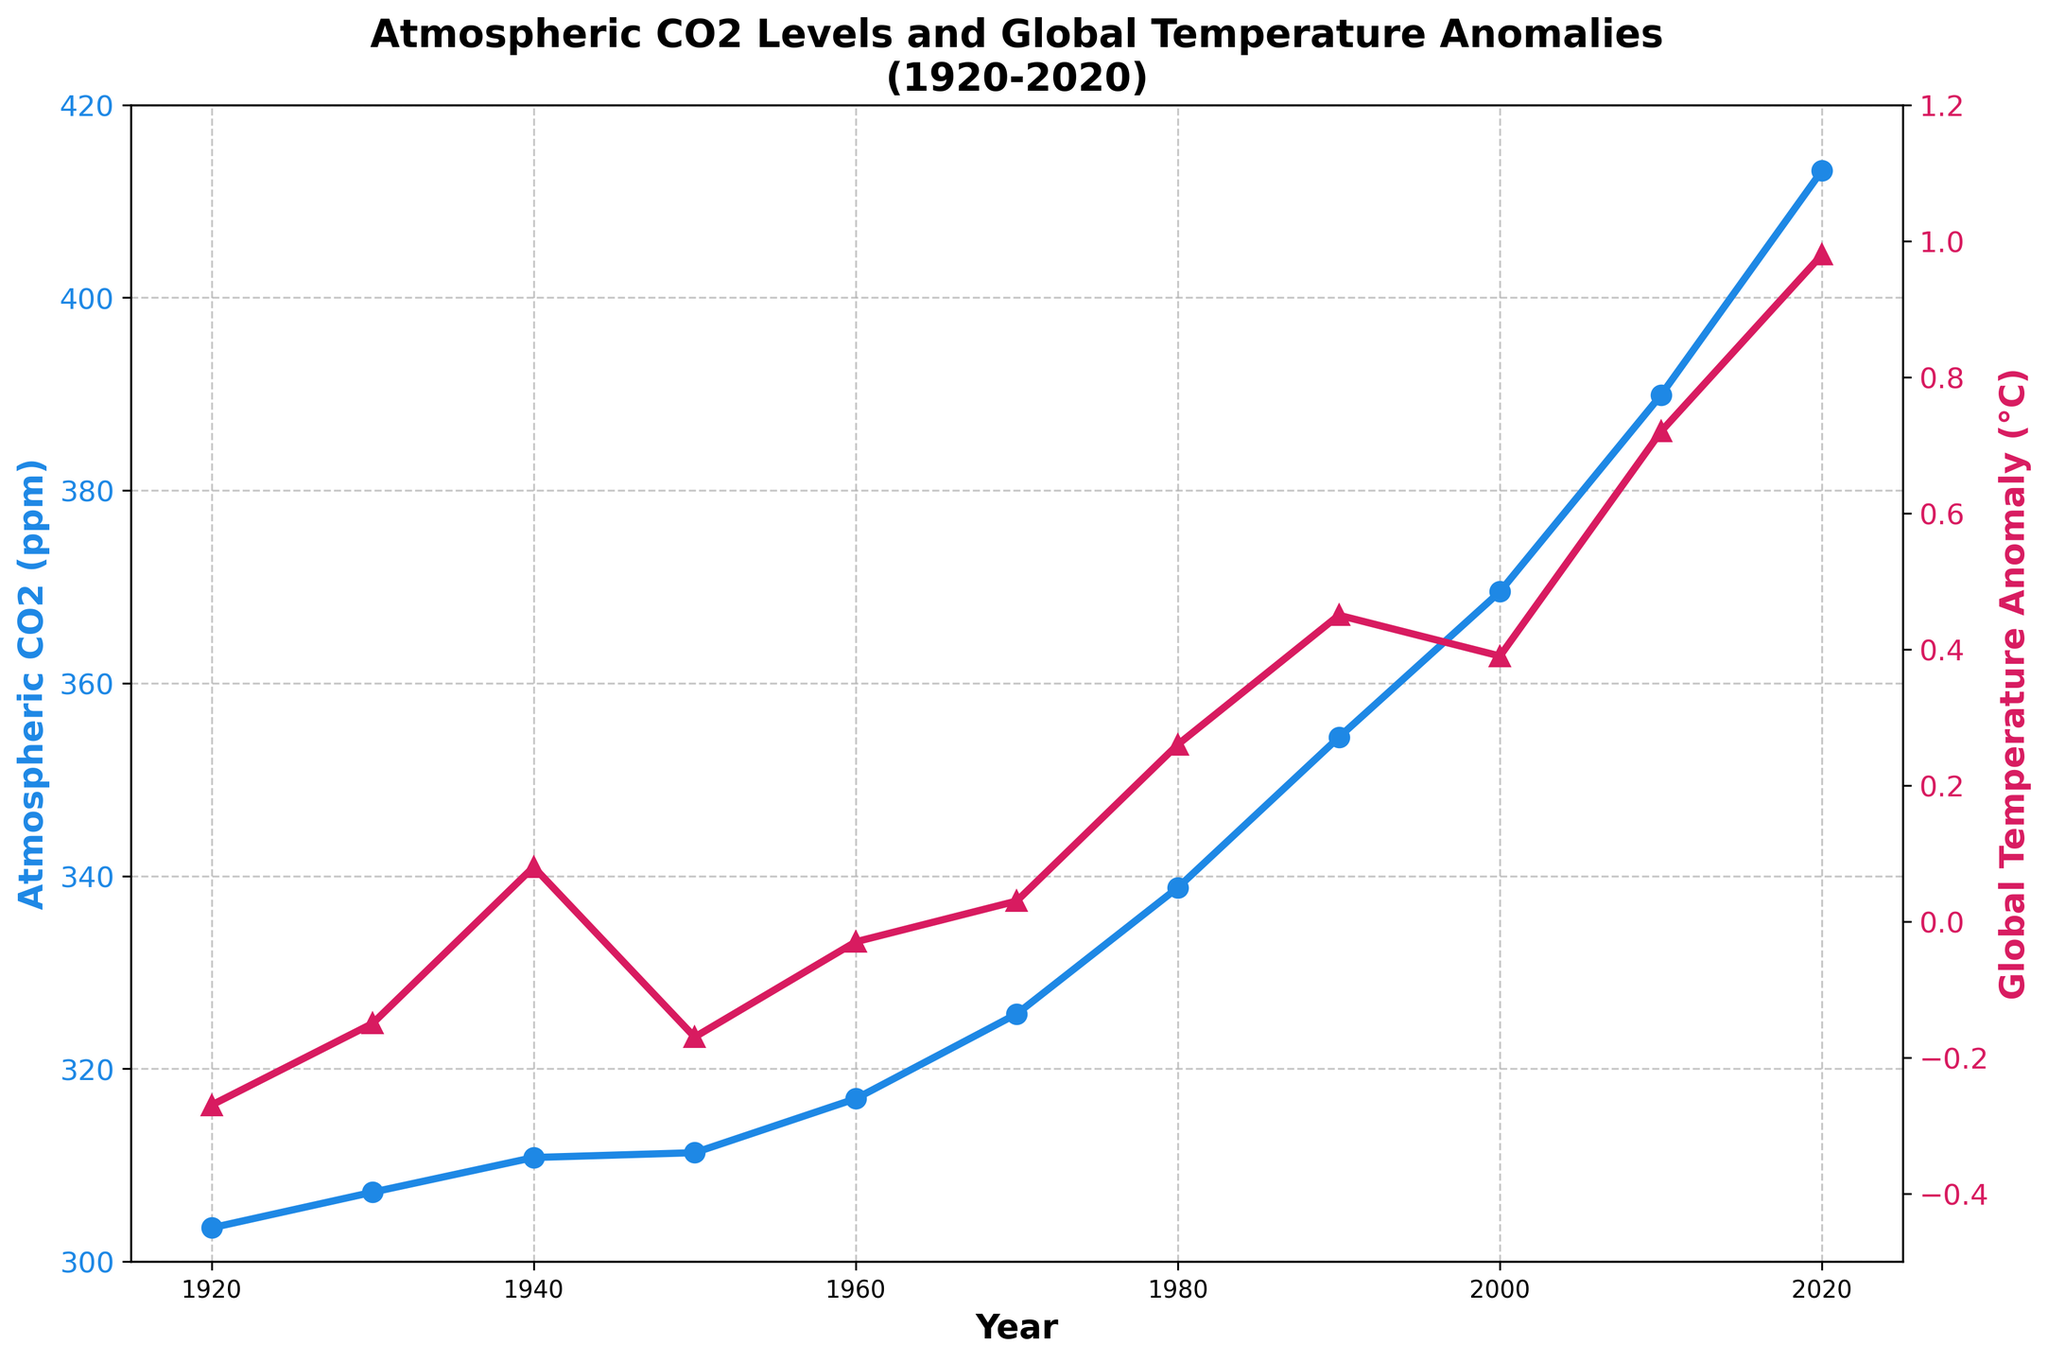What year had the highest atmospheric CO2 levels? Look at the blue line plot and find the highest point, which corresponds to the year 2020.
Answer: 2020 What is the overall trend in global temperature anomalies from 1920 to 2020? Observe the red line plot and note that it generally increases from around -0.27°C in 1920 to 0.98°C in 2020.
Answer: Increasing How much did atmospheric CO2 levels increase between 1930 and 2020? Find the CO2 levels for 1930 (307.2 ppm) and 2020 (413.2 ppm) and calculate the difference: 413.2 - 307.2.
Answer: 106 ppm Which year had a higher global temperature anomaly: 1980 or 1950? Compare the red dots for 1980 (0.26°C) and 1950 (-0.17°C) and see that 1980 is higher.
Answer: 1980 What is the difference in atmospheric CO2 levels between the years 1960 and 1940? Find the CO2 levels for 1960 (316.9 ppm) and 1940 (310.8 ppm) and calculate the difference: 316.9 - 310.8.
Answer: 6.1 ppm What visual pattern do you observe between atmospheric CO2 levels and global temperature anomalies? Both the blue and red lines show an upward trend, indicating a potential correlation between increasing CO2 levels and rising temperature anomalies over time.
Answer: Upward trend What is the rate of change in global temperature anomaly from 2000 to 2020? Find the difference in temperature anomalies (2020: 0.98°C and 2000: 0.39°C) and divide by the 20-year interval: (0.98 - 0.39) / 20.
Answer: 0.0295°C per year In which decade did atmospheric CO2 levels first exceed 350 ppm? Look for the decade where the blue line crosses above 350 ppm, which occurs between 1980 and 1990.
Answer: 1980s What is the average global temperature anomaly over the given years? Sum the temperature anomalies and divide by the number of data points: (-0.27 - 0.15 + 0.08 - 0.17 - 0.03 + 0.03 + 0.26 + 0.45 + 0.39 + 0.72 + 0.98) / 11.
Answer: 0.121°C 